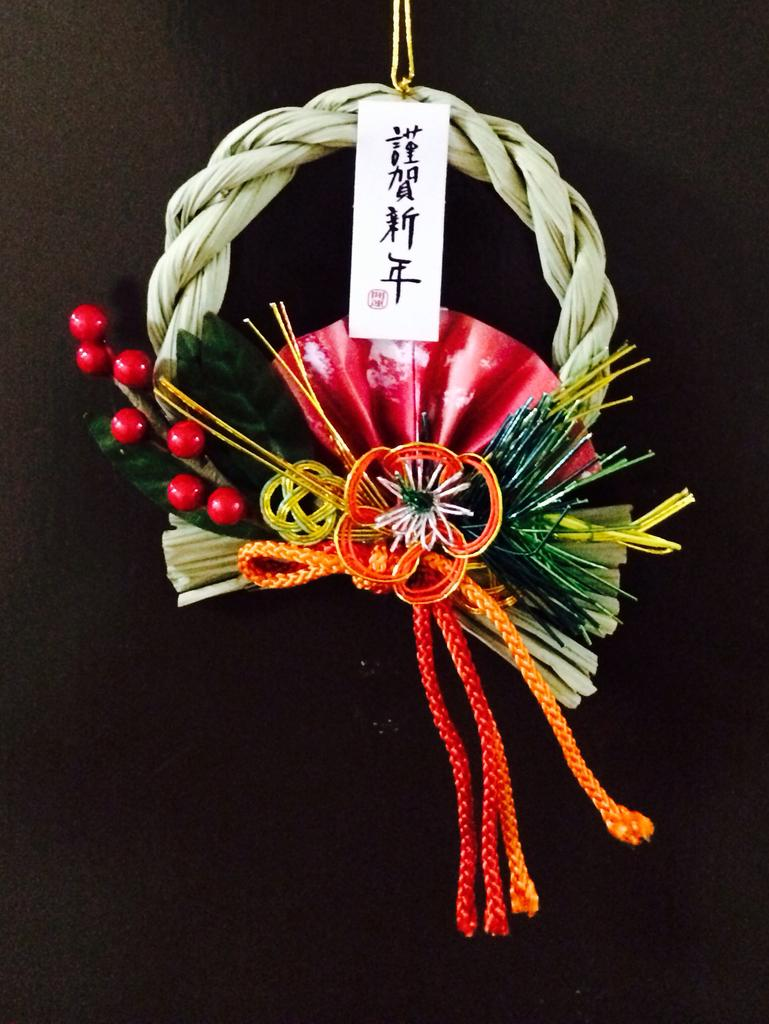What is the general color scheme of the image? The background of the image is dark. Can you identify any objects in the image that stand out due to their color? Yes, there is a colorful object in the image. What is the purpose of the white card in the image? There is something written on a white card in the image. What day of the week is depicted on the colorful object in the image? There is no indication of a specific day of the week on the colorful object in the image. 